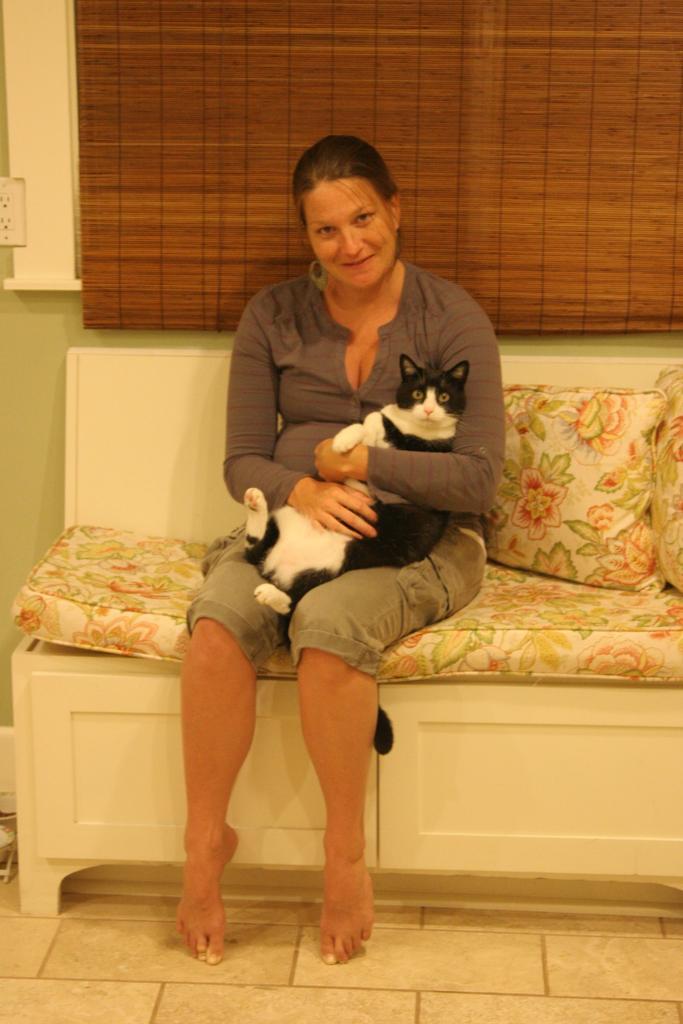Can you describe this image briefly? This image is taken indoors. At the bottom of the image there is a floor. In the background there is a wall and there is a wooden window blind. In the middle of the image a woman is sitting on the couch and she is holding a cat in her hands. She is with a smiling face. On the right side of the image there is a couch with two pillows on it. 